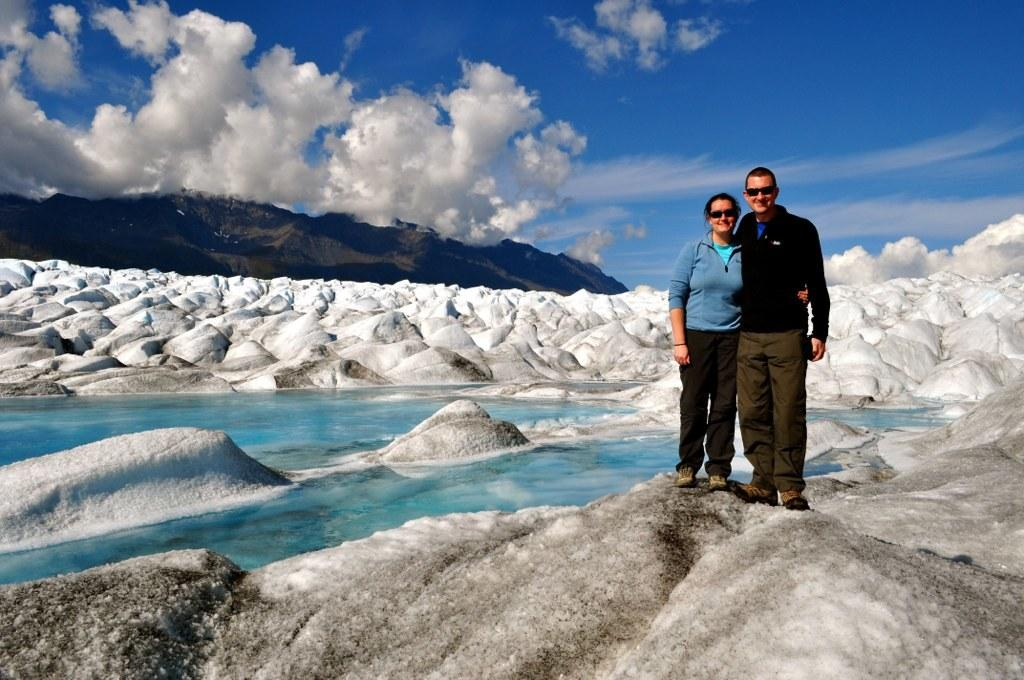Who are the people in the image? There is a woman and a man on the right side of the image. What is in the middle of the image? There is water and snow in the middle of the image. What can be seen in the background of the image? There are hills in the background of the image. What is visible at the top of the image? The sky is visible at the top of the image. What type of berry can be heard in the image? There is no berry present in the image, and therefore no sound can be heard from it. What rhythm is the snow following in the image? The snow is not following any rhythm in the image; it is stationary. 